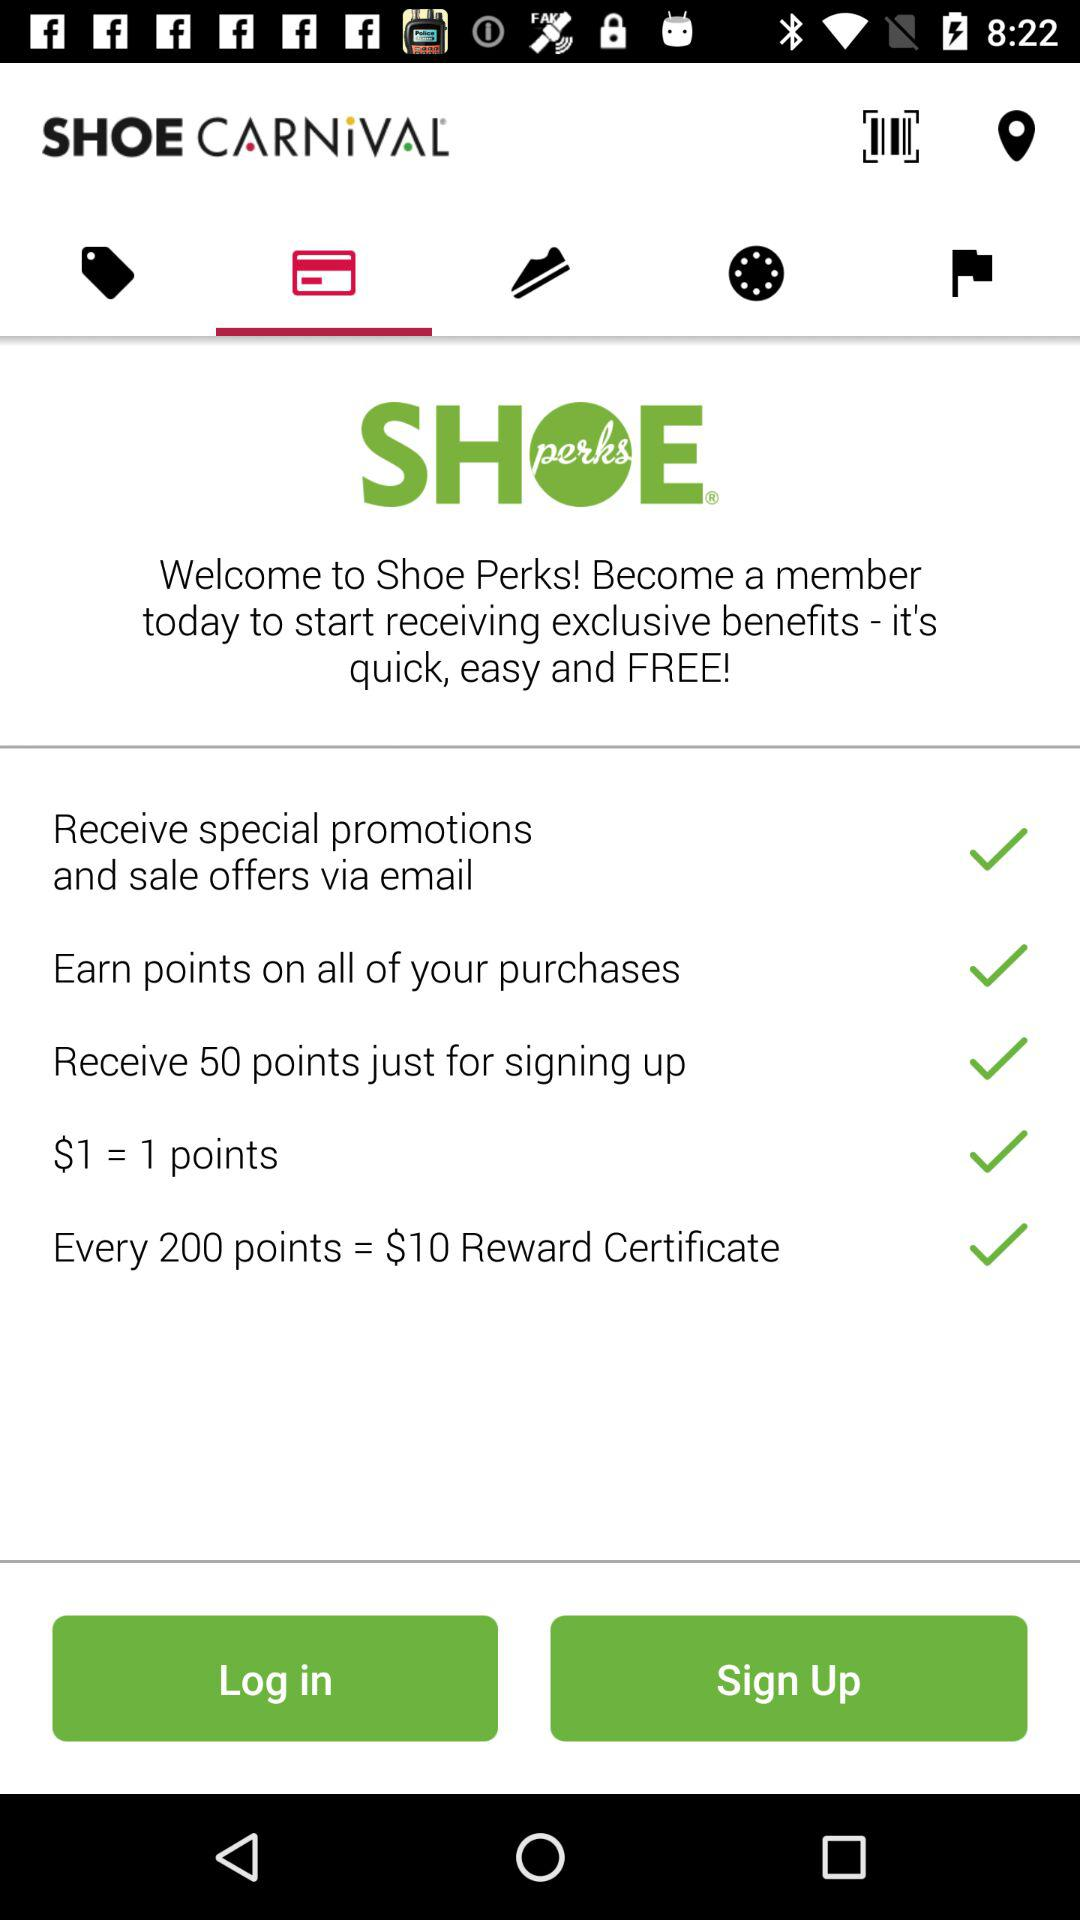How many points are required to receive a $10 reward certificate?
Answer the question using a single word or phrase. 200 